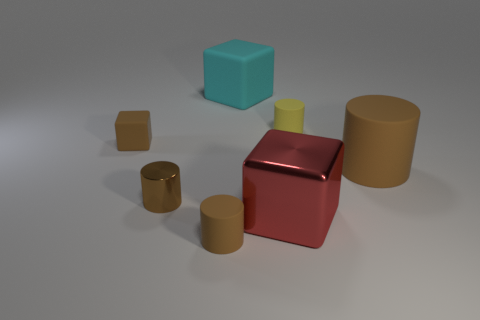There is a big brown matte object; what number of brown matte cylinders are behind it?
Make the answer very short. 0. There is a big matte object behind the tiny brown cube; does it have the same shape as the tiny thing in front of the large metal object?
Offer a very short reply. No. What shape is the matte object that is both to the right of the large cyan object and in front of the tiny yellow rubber thing?
Give a very brief answer. Cylinder. There is a brown cylinder that is the same material as the red block; what is its size?
Keep it short and to the point. Small. Is the number of metal cubes less than the number of large blue matte cylinders?
Your response must be concise. No. There is a brown object behind the brown cylinder that is right of the tiny rubber cylinder in front of the tiny matte block; what is its material?
Offer a very short reply. Rubber. Is the material of the small cylinder behind the large cylinder the same as the big cube that is in front of the yellow rubber cylinder?
Your response must be concise. No. What is the size of the brown cylinder that is behind the red thing and left of the cyan matte object?
Provide a succinct answer. Small. What material is the cyan object that is the same size as the red cube?
Offer a terse response. Rubber. There is a big block that is in front of the small brown rubber thing behind the large shiny thing; what number of brown things are in front of it?
Keep it short and to the point. 1. 